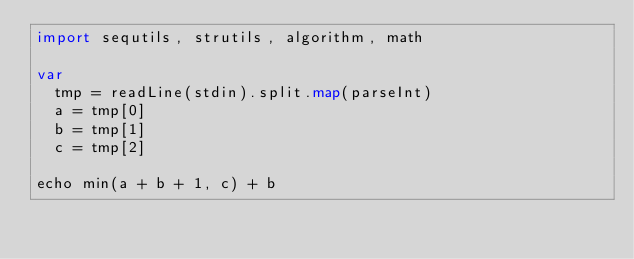Convert code to text. <code><loc_0><loc_0><loc_500><loc_500><_Nim_>import sequtils, strutils, algorithm, math

var
  tmp = readLine(stdin).split.map(parseInt)
  a = tmp[0]
  b = tmp[1]
  c = tmp[2]

echo min(a + b + 1, c) + b</code> 